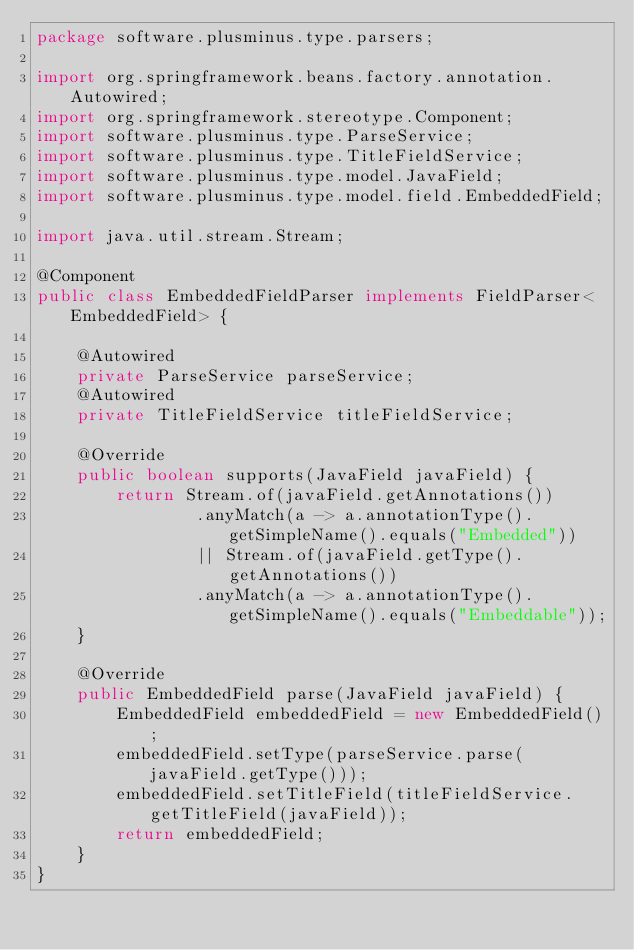<code> <loc_0><loc_0><loc_500><loc_500><_Java_>package software.plusminus.type.parsers;

import org.springframework.beans.factory.annotation.Autowired;
import org.springframework.stereotype.Component;
import software.plusminus.type.ParseService;
import software.plusminus.type.TitleFieldService;
import software.plusminus.type.model.JavaField;
import software.plusminus.type.model.field.EmbeddedField;

import java.util.stream.Stream;

@Component
public class EmbeddedFieldParser implements FieldParser<EmbeddedField> {

    @Autowired
    private ParseService parseService;
    @Autowired
    private TitleFieldService titleFieldService;

    @Override
    public boolean supports(JavaField javaField) {
        return Stream.of(javaField.getAnnotations())
                .anyMatch(a -> a.annotationType().getSimpleName().equals("Embedded"))
                || Stream.of(javaField.getType().getAnnotations())
                .anyMatch(a -> a.annotationType().getSimpleName().equals("Embeddable"));
    }

    @Override
    public EmbeddedField parse(JavaField javaField) {
        EmbeddedField embeddedField = new EmbeddedField();
        embeddedField.setType(parseService.parse(javaField.getType()));
        embeddedField.setTitleField(titleFieldService.getTitleField(javaField));
        return embeddedField;
    }
}
</code> 